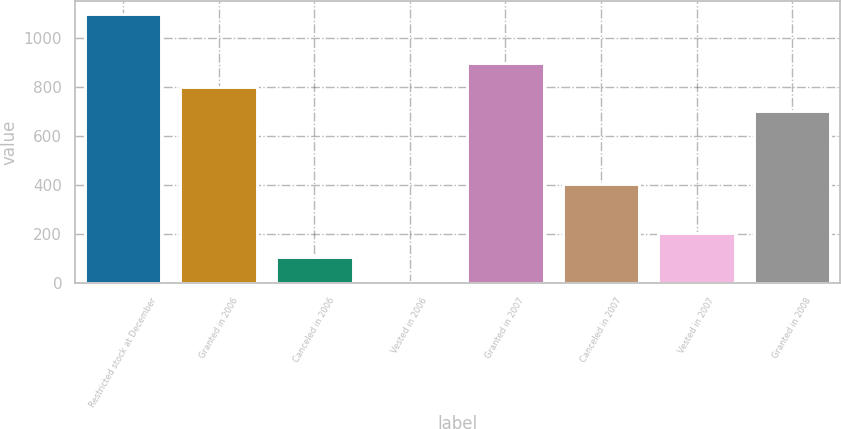Convert chart. <chart><loc_0><loc_0><loc_500><loc_500><bar_chart><fcel>Restricted stock at December<fcel>Granted in 2006<fcel>Canceled in 2006<fcel>Vested in 2006<fcel>Granted in 2007<fcel>Canceled in 2007<fcel>Vested in 2007<fcel>Granted in 2008<nl><fcel>1096.1<fcel>798.8<fcel>105.1<fcel>6<fcel>897.9<fcel>402.4<fcel>204.2<fcel>699.7<nl></chart> 